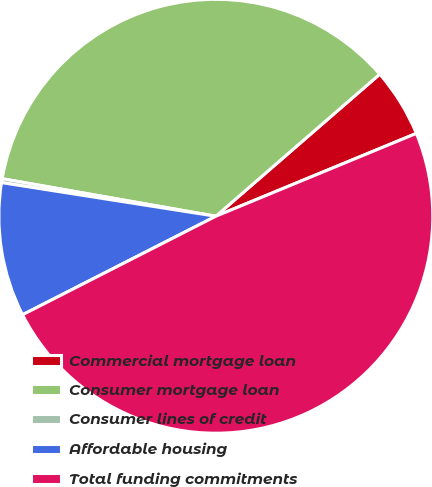<chart> <loc_0><loc_0><loc_500><loc_500><pie_chart><fcel>Commercial mortgage loan<fcel>Consumer mortgage loan<fcel>Consumer lines of credit<fcel>Affordable housing<fcel>Total funding commitments<nl><fcel>5.13%<fcel>35.87%<fcel>0.29%<fcel>9.98%<fcel>48.74%<nl></chart> 